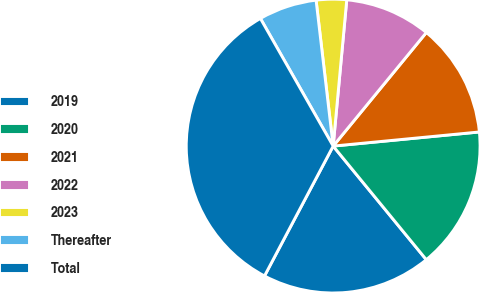Convert chart to OTSL. <chart><loc_0><loc_0><loc_500><loc_500><pie_chart><fcel>2019<fcel>2020<fcel>2021<fcel>2022<fcel>2023<fcel>Thereafter<fcel>Total<nl><fcel>18.67%<fcel>15.6%<fcel>12.53%<fcel>9.46%<fcel>3.33%<fcel>6.39%<fcel>34.01%<nl></chart> 